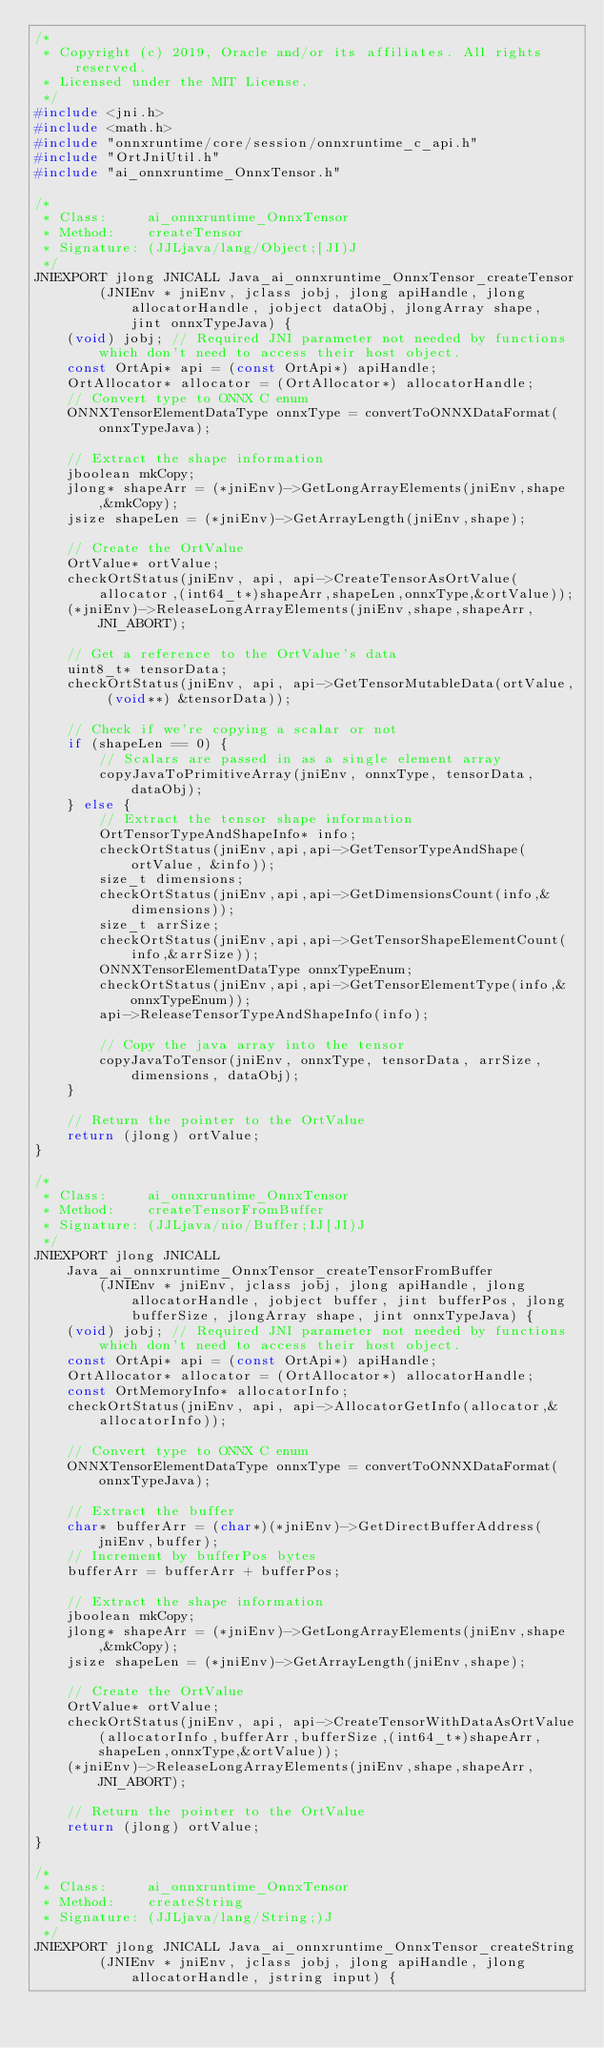<code> <loc_0><loc_0><loc_500><loc_500><_C_>/*
 * Copyright (c) 2019, Oracle and/or its affiliates. All rights reserved.
 * Licensed under the MIT License.
 */
#include <jni.h>
#include <math.h>
#include "onnxruntime/core/session/onnxruntime_c_api.h"
#include "OrtJniUtil.h"
#include "ai_onnxruntime_OnnxTensor.h"

/*
 * Class:     ai_onnxruntime_OnnxTensor
 * Method:    createTensor
 * Signature: (JJLjava/lang/Object;[JI)J
 */
JNIEXPORT jlong JNICALL Java_ai_onnxruntime_OnnxTensor_createTensor
        (JNIEnv * jniEnv, jclass jobj, jlong apiHandle, jlong allocatorHandle, jobject dataObj, jlongArray shape, jint onnxTypeJava) {
    (void) jobj; // Required JNI parameter not needed by functions which don't need to access their host object.
    const OrtApi* api = (const OrtApi*) apiHandle;
    OrtAllocator* allocator = (OrtAllocator*) allocatorHandle;
    // Convert type to ONNX C enum
    ONNXTensorElementDataType onnxType = convertToONNXDataFormat(onnxTypeJava);

    // Extract the shape information
    jboolean mkCopy;
    jlong* shapeArr = (*jniEnv)->GetLongArrayElements(jniEnv,shape,&mkCopy);
    jsize shapeLen = (*jniEnv)->GetArrayLength(jniEnv,shape);

    // Create the OrtValue
    OrtValue* ortValue;
    checkOrtStatus(jniEnv, api, api->CreateTensorAsOrtValue(allocator,(int64_t*)shapeArr,shapeLen,onnxType,&ortValue));
    (*jniEnv)->ReleaseLongArrayElements(jniEnv,shape,shapeArr,JNI_ABORT);

    // Get a reference to the OrtValue's data
    uint8_t* tensorData;
    checkOrtStatus(jniEnv, api, api->GetTensorMutableData(ortValue, (void**) &tensorData));

    // Check if we're copying a scalar or not
    if (shapeLen == 0) {
        // Scalars are passed in as a single element array
        copyJavaToPrimitiveArray(jniEnv, onnxType, tensorData, dataObj);
    } else {
        // Extract the tensor shape information
        OrtTensorTypeAndShapeInfo* info;
        checkOrtStatus(jniEnv,api,api->GetTensorTypeAndShape(ortValue, &info));
        size_t dimensions;
        checkOrtStatus(jniEnv,api,api->GetDimensionsCount(info,&dimensions));
        size_t arrSize;
        checkOrtStatus(jniEnv,api,api->GetTensorShapeElementCount(info,&arrSize));
        ONNXTensorElementDataType onnxTypeEnum;
        checkOrtStatus(jniEnv,api,api->GetTensorElementType(info,&onnxTypeEnum));
        api->ReleaseTensorTypeAndShapeInfo(info);

        // Copy the java array into the tensor
        copyJavaToTensor(jniEnv, onnxType, tensorData, arrSize, dimensions, dataObj);
    }

    // Return the pointer to the OrtValue
    return (jlong) ortValue;
}

/*
 * Class:     ai_onnxruntime_OnnxTensor
 * Method:    createTensorFromBuffer
 * Signature: (JJLjava/nio/Buffer;IJ[JI)J
 */
JNIEXPORT jlong JNICALL Java_ai_onnxruntime_OnnxTensor_createTensorFromBuffer
        (JNIEnv * jniEnv, jclass jobj, jlong apiHandle, jlong allocatorHandle, jobject buffer, jint bufferPos, jlong bufferSize, jlongArray shape, jint onnxTypeJava) {
    (void) jobj; // Required JNI parameter not needed by functions which don't need to access their host object.
    const OrtApi* api = (const OrtApi*) apiHandle;
    OrtAllocator* allocator = (OrtAllocator*) allocatorHandle;
    const OrtMemoryInfo* allocatorInfo;
    checkOrtStatus(jniEnv, api, api->AllocatorGetInfo(allocator,&allocatorInfo));

    // Convert type to ONNX C enum
    ONNXTensorElementDataType onnxType = convertToONNXDataFormat(onnxTypeJava);

    // Extract the buffer
    char* bufferArr = (char*)(*jniEnv)->GetDirectBufferAddress(jniEnv,buffer);
    // Increment by bufferPos bytes
    bufferArr = bufferArr + bufferPos;

    // Extract the shape information
    jboolean mkCopy;
    jlong* shapeArr = (*jniEnv)->GetLongArrayElements(jniEnv,shape,&mkCopy);
    jsize shapeLen = (*jniEnv)->GetArrayLength(jniEnv,shape);

    // Create the OrtValue
    OrtValue* ortValue;
    checkOrtStatus(jniEnv, api, api->CreateTensorWithDataAsOrtValue(allocatorInfo,bufferArr,bufferSize,(int64_t*)shapeArr,shapeLen,onnxType,&ortValue));
    (*jniEnv)->ReleaseLongArrayElements(jniEnv,shape,shapeArr,JNI_ABORT);

    // Return the pointer to the OrtValue
    return (jlong) ortValue;
}

/*
 * Class:     ai_onnxruntime_OnnxTensor
 * Method:    createString
 * Signature: (JJLjava/lang/String;)J
 */
JNIEXPORT jlong JNICALL Java_ai_onnxruntime_OnnxTensor_createString
        (JNIEnv * jniEnv, jclass jobj, jlong apiHandle, jlong allocatorHandle, jstring input) {</code> 